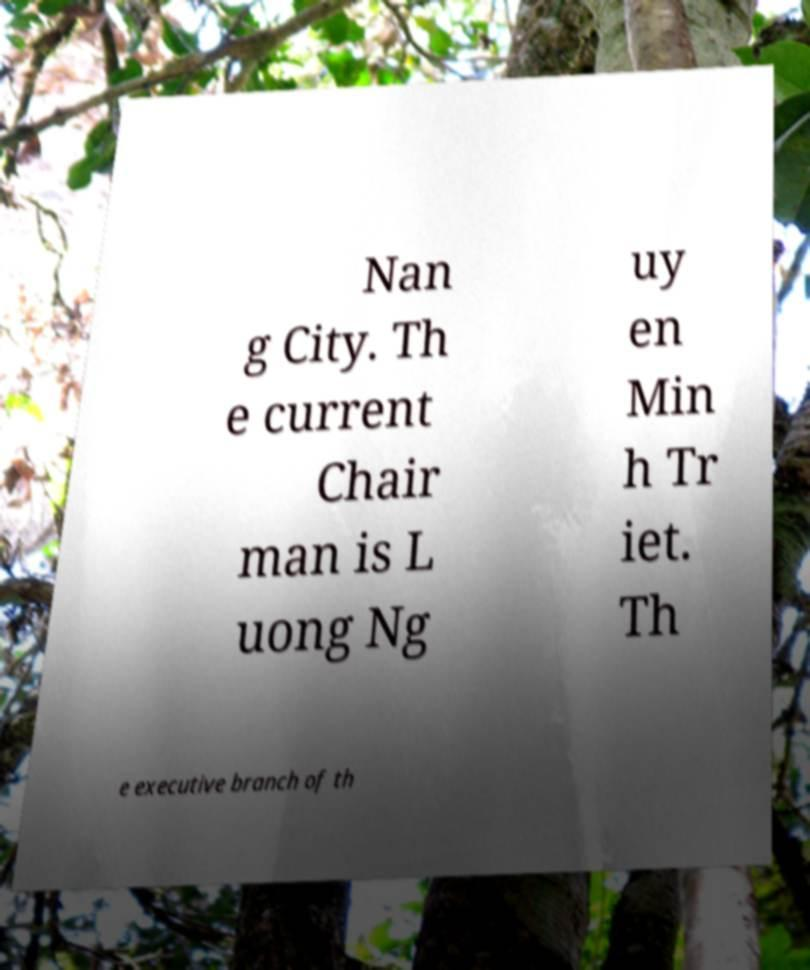Could you extract and type out the text from this image? Nan g City. Th e current Chair man is L uong Ng uy en Min h Tr iet. Th e executive branch of th 